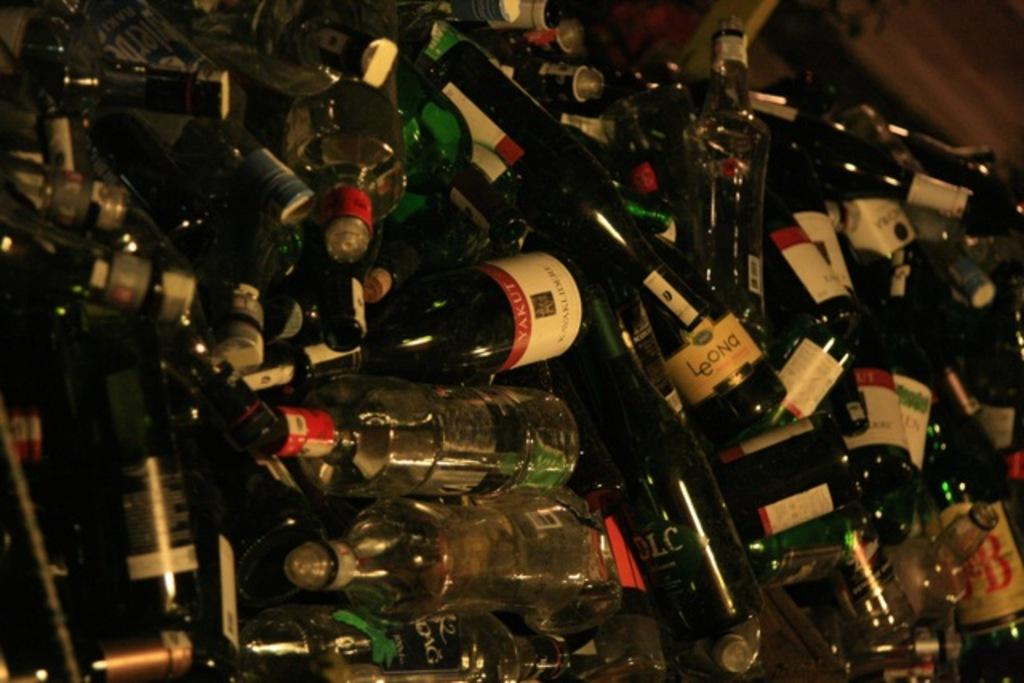Provide a one-sentence caption for the provided image. Hundreds of discarded glass bottles, including Yakut, in a bin. 